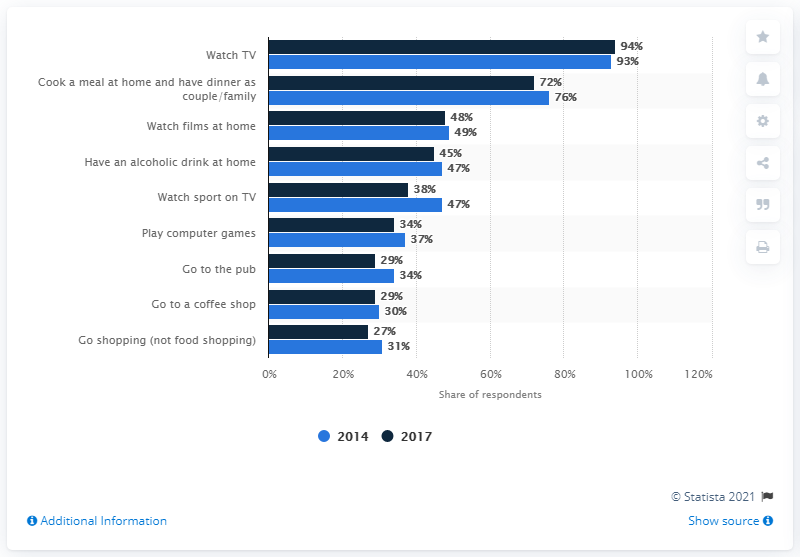Identify some key points in this picture. In 2014, the number of people who watched films at home was 1 million. In 2017, the number of people who watched films at home increased to 2 million, indicating a difference of 1 million people. In 2017, 29% of respondents reported that they visited a pub on a weekly basis. In 2014, the majority of people engaged in the activity of watching television. 